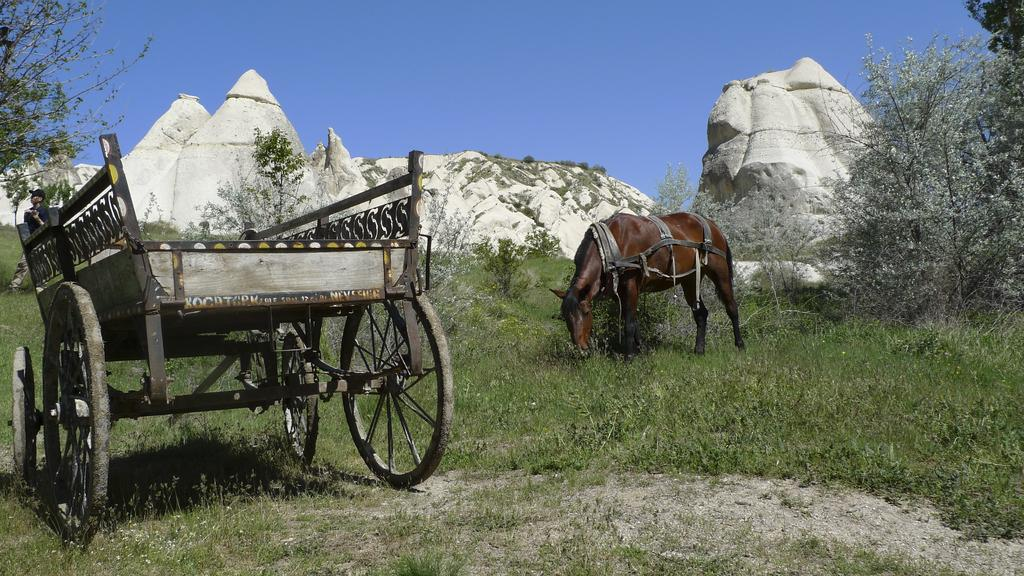What is the main subject of the image? The main subject of the image is a cart and a horse. Where are the cart and horse located? The cart and horse are on the grass. Who is present in the image? There is a person in the image. What type of natural environment is visible in the image? Trees, plants, and rocks are visible in the image. What is visible in the background of the image? The sky is visible in the background of the image. What type of circle can be seen on the horse's back in the image? There is no circle visible on the horse's back in the image. What sound do the bells make in the image? There are no bells present in the image. 